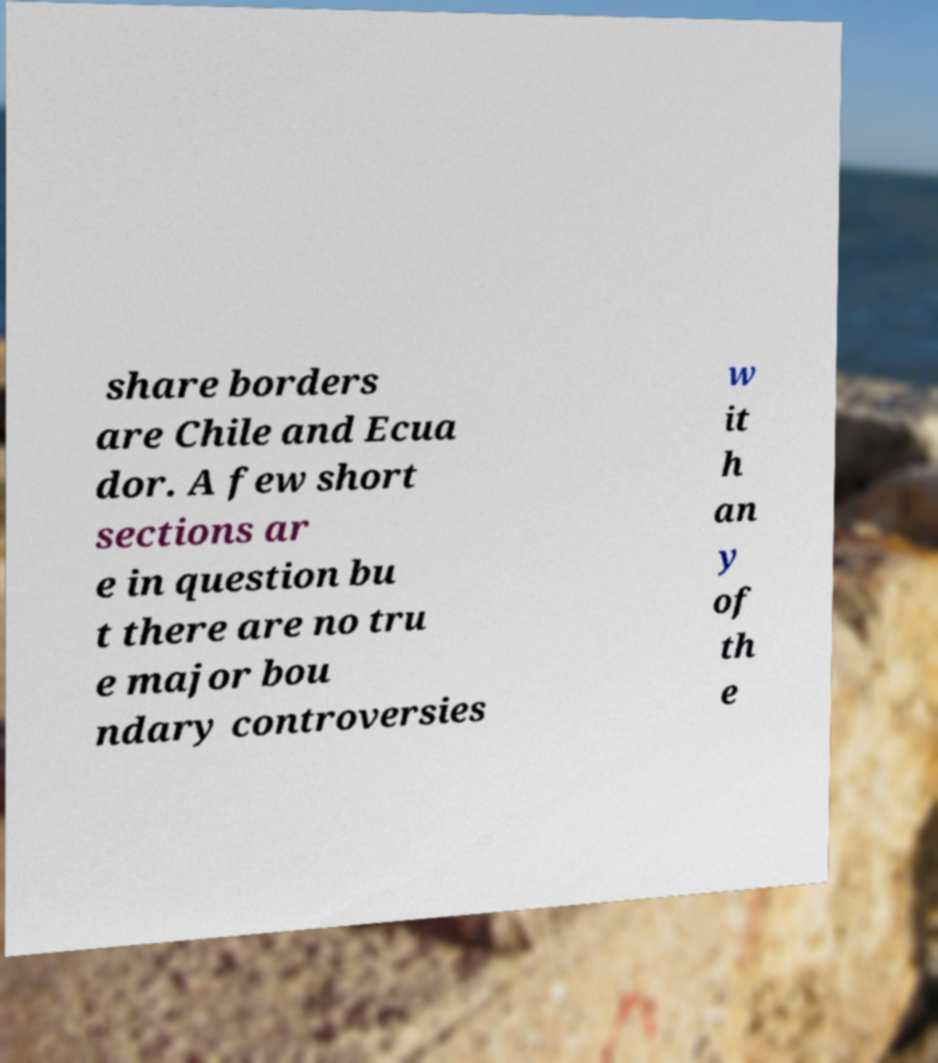Please identify and transcribe the text found in this image. share borders are Chile and Ecua dor. A few short sections ar e in question bu t there are no tru e major bou ndary controversies w it h an y of th e 